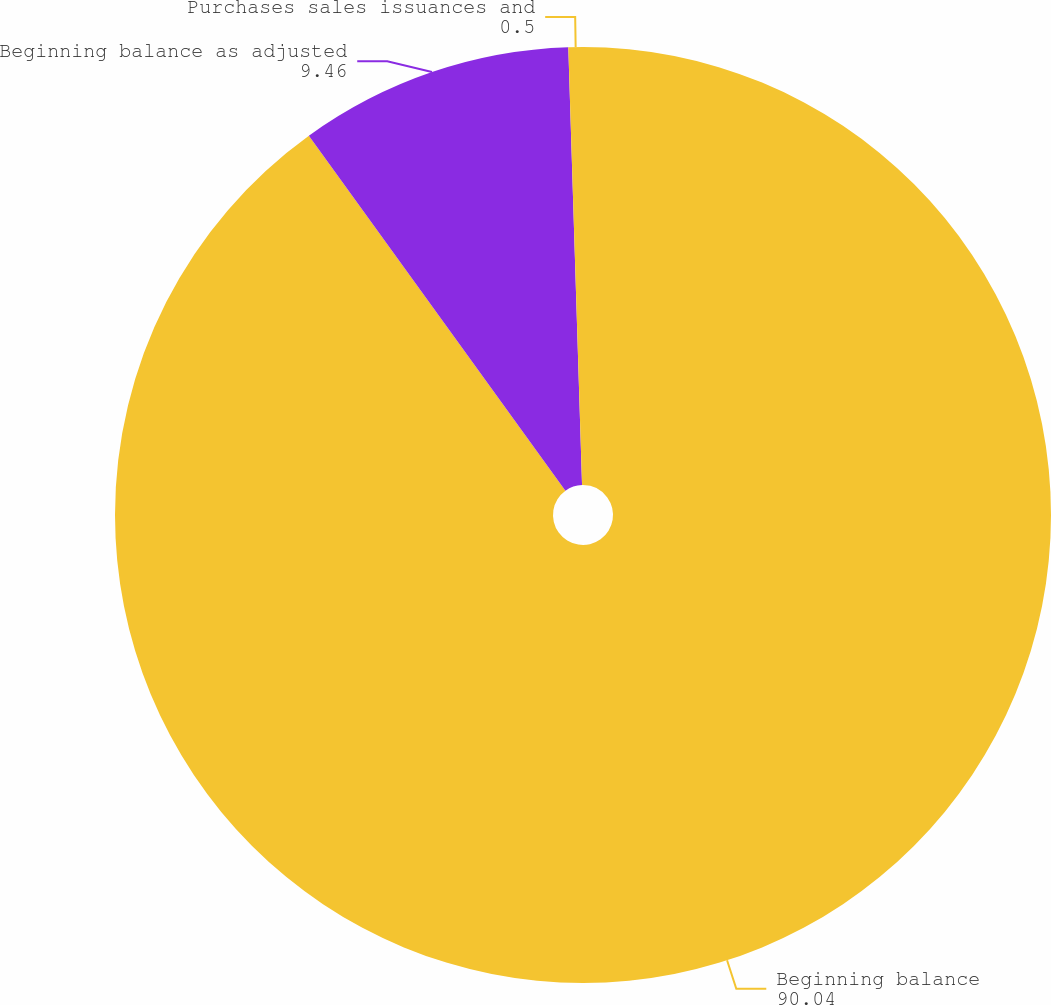Convert chart. <chart><loc_0><loc_0><loc_500><loc_500><pie_chart><fcel>Beginning balance<fcel>Beginning balance as adjusted<fcel>Purchases sales issuances and<nl><fcel>90.04%<fcel>9.46%<fcel>0.5%<nl></chart> 